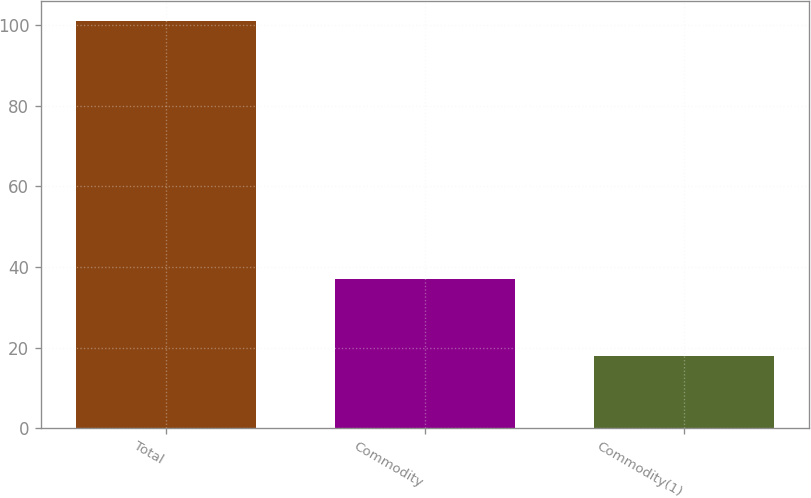<chart> <loc_0><loc_0><loc_500><loc_500><bar_chart><fcel>Total<fcel>Commodity<fcel>Commodity(1)<nl><fcel>101<fcel>37<fcel>18<nl></chart> 